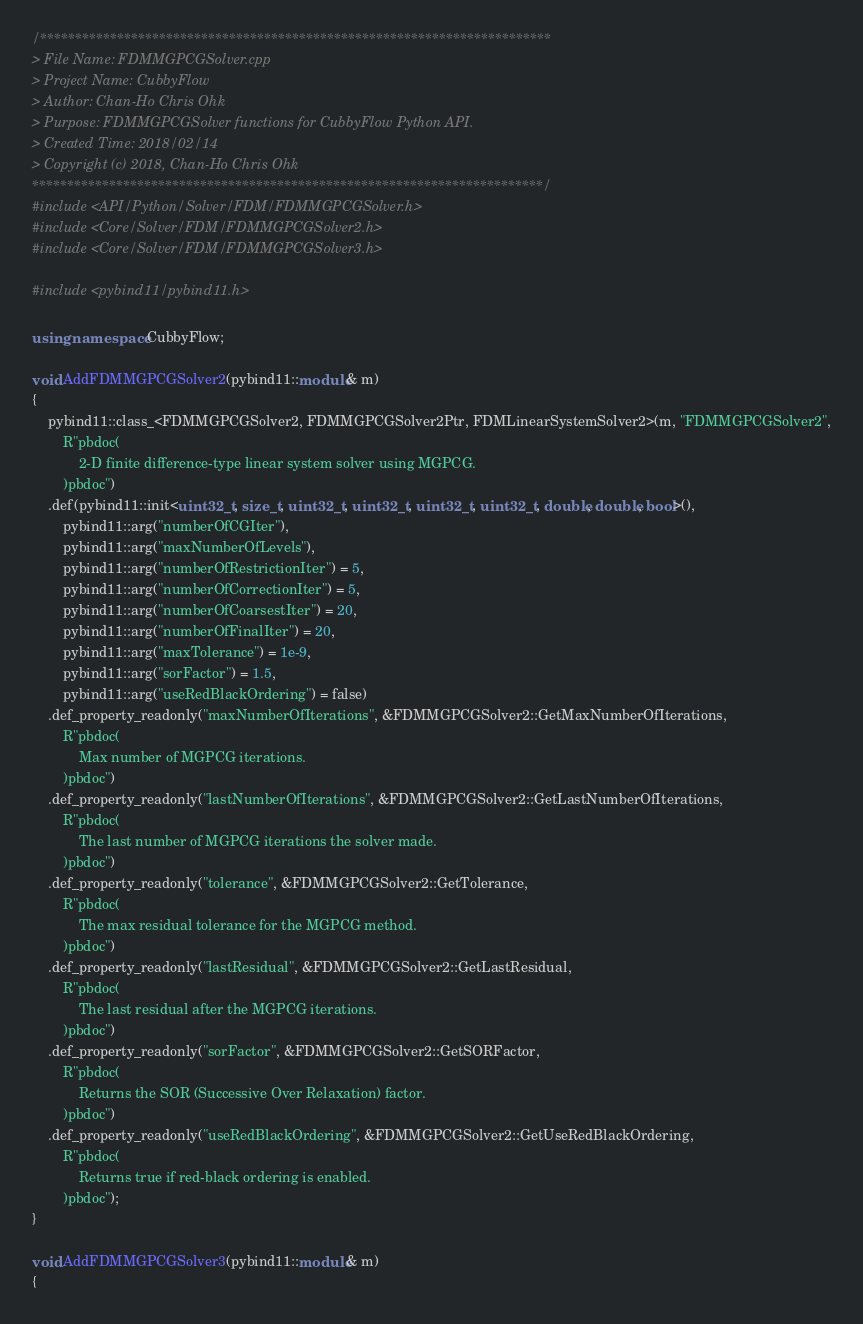Convert code to text. <code><loc_0><loc_0><loc_500><loc_500><_C++_>/*************************************************************************
> File Name: FDMMGPCGSolver.cpp
> Project Name: CubbyFlow
> Author: Chan-Ho Chris Ohk
> Purpose: FDMMGPCGSolver functions for CubbyFlow Python API.
> Created Time: 2018/02/14
> Copyright (c) 2018, Chan-Ho Chris Ohk
*************************************************************************/
#include <API/Python/Solver/FDM/FDMMGPCGSolver.h>
#include <Core/Solver/FDM/FDMMGPCGSolver2.h>
#include <Core/Solver/FDM/FDMMGPCGSolver3.h>

#include <pybind11/pybind11.h>

using namespace CubbyFlow;

void AddFDMMGPCGSolver2(pybind11::module& m)
{
	pybind11::class_<FDMMGPCGSolver2, FDMMGPCGSolver2Ptr, FDMLinearSystemSolver2>(m, "FDMMGPCGSolver2",
		R"pbdoc(
			2-D finite difference-type linear system solver using MGPCG.
		)pbdoc")
	.def(pybind11::init<uint32_t, size_t, uint32_t, uint32_t, uint32_t, uint32_t, double, double, bool>(),
		pybind11::arg("numberOfCGIter"),
		pybind11::arg("maxNumberOfLevels"),
		pybind11::arg("numberOfRestrictionIter") = 5,
		pybind11::arg("numberOfCorrectionIter") = 5,
		pybind11::arg("numberOfCoarsestIter") = 20,
		pybind11::arg("numberOfFinalIter") = 20,
		pybind11::arg("maxTolerance") = 1e-9,
		pybind11::arg("sorFactor") = 1.5,
		pybind11::arg("useRedBlackOrdering") = false)
	.def_property_readonly("maxNumberOfIterations", &FDMMGPCGSolver2::GetMaxNumberOfIterations,
		R"pbdoc(
			Max number of MGPCG iterations.
		)pbdoc")
	.def_property_readonly("lastNumberOfIterations", &FDMMGPCGSolver2::GetLastNumberOfIterations,
		R"pbdoc(
			The last number of MGPCG iterations the solver made.
		)pbdoc")
	.def_property_readonly("tolerance", &FDMMGPCGSolver2::GetTolerance,
		R"pbdoc(
			The max residual tolerance for the MGPCG method.
		)pbdoc")
	.def_property_readonly("lastResidual", &FDMMGPCGSolver2::GetLastResidual,
		R"pbdoc(
			The last residual after the MGPCG iterations.
		)pbdoc")
	.def_property_readonly("sorFactor", &FDMMGPCGSolver2::GetSORFactor,
		R"pbdoc(
			Returns the SOR (Successive Over Relaxation) factor.
		)pbdoc")
	.def_property_readonly("useRedBlackOrdering", &FDMMGPCGSolver2::GetUseRedBlackOrdering,
		R"pbdoc(
			Returns true if red-black ordering is enabled.
		)pbdoc");
}

void AddFDMMGPCGSolver3(pybind11::module& m)
{</code> 